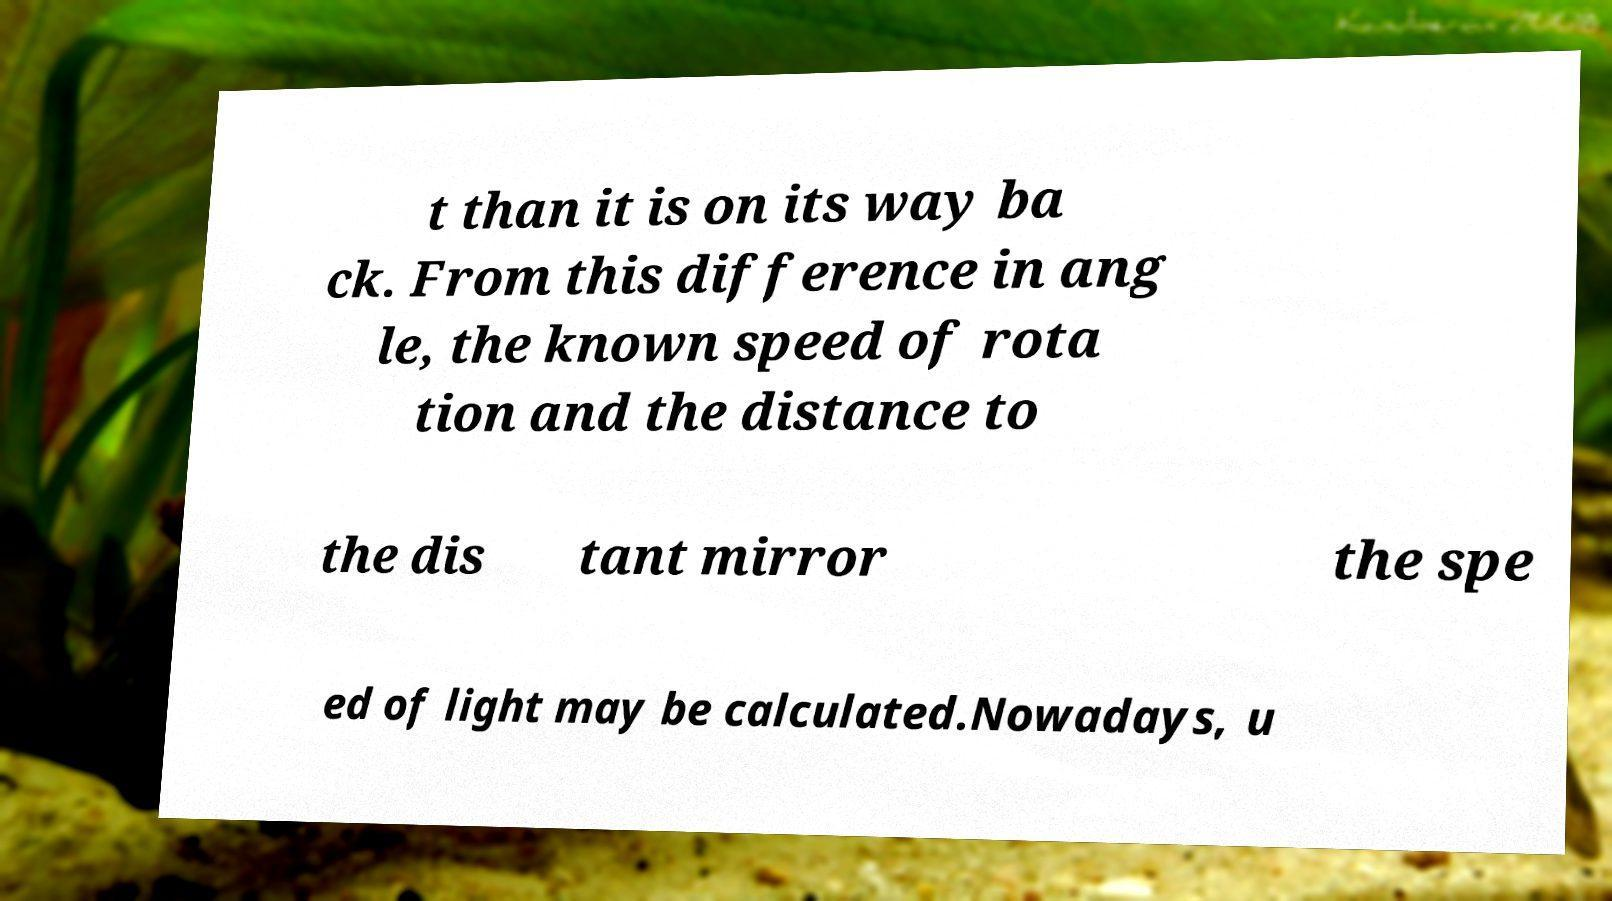Please identify and transcribe the text found in this image. t than it is on its way ba ck. From this difference in ang le, the known speed of rota tion and the distance to the dis tant mirror the spe ed of light may be calculated.Nowadays, u 